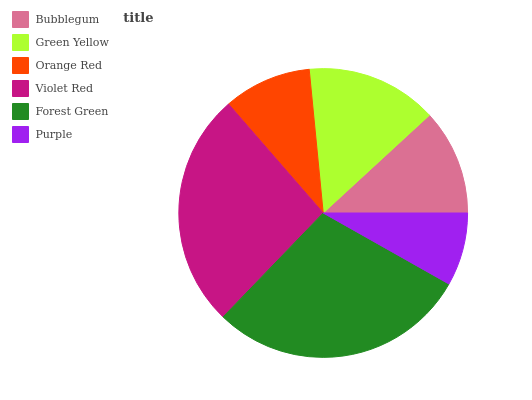Is Purple the minimum?
Answer yes or no. Yes. Is Forest Green the maximum?
Answer yes or no. Yes. Is Green Yellow the minimum?
Answer yes or no. No. Is Green Yellow the maximum?
Answer yes or no. No. Is Green Yellow greater than Bubblegum?
Answer yes or no. Yes. Is Bubblegum less than Green Yellow?
Answer yes or no. Yes. Is Bubblegum greater than Green Yellow?
Answer yes or no. No. Is Green Yellow less than Bubblegum?
Answer yes or no. No. Is Green Yellow the high median?
Answer yes or no. Yes. Is Bubblegum the low median?
Answer yes or no. Yes. Is Orange Red the high median?
Answer yes or no. No. Is Orange Red the low median?
Answer yes or no. No. 